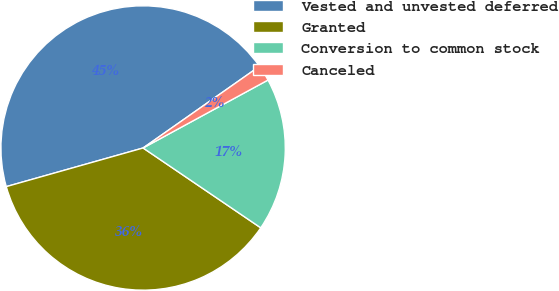<chart> <loc_0><loc_0><loc_500><loc_500><pie_chart><fcel>Vested and unvested deferred<fcel>Granted<fcel>Conversion to common stock<fcel>Canceled<nl><fcel>44.64%<fcel>36.13%<fcel>17.42%<fcel>1.81%<nl></chart> 